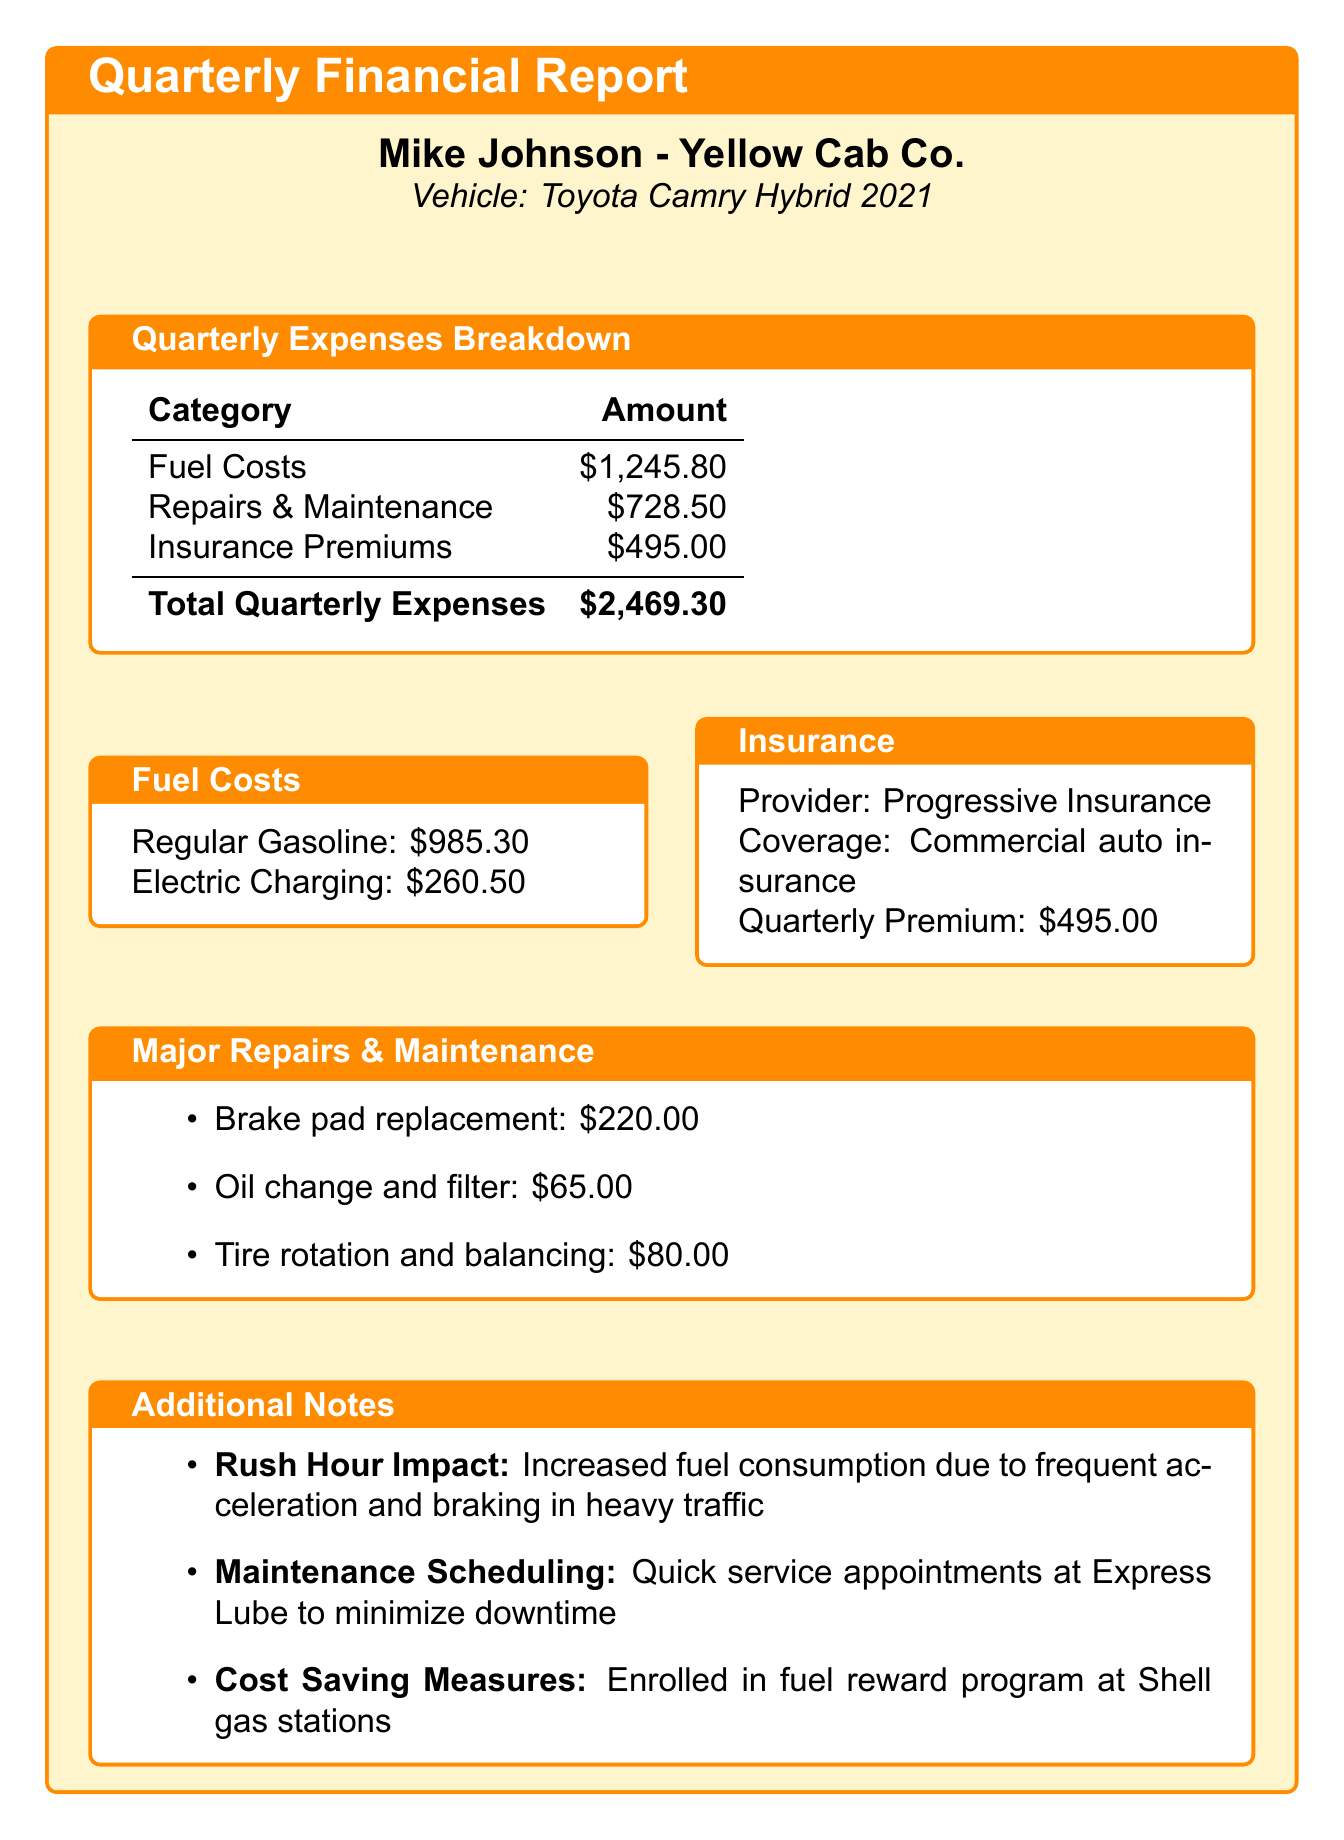What is the total quarterly expenses? The total quarterly expenses are summarized at the end of the document, which includes all costs.
Answer: $2,469.30 Who is the insurance provider? The document lists the insurance provider under the insurance section, identifying who covers the insurance.
Answer: Progressive Insurance What is the cost of the brake pad replacement? The cost for the brake pad replacement is detailed in the repairs and maintenance section, showing a specific repair expense.
Answer: $220.00 How much was spent on electric charging? The breakdown of fuel costs provides specific figures for electric charging, indicating the amount spent.
Answer: $260.50 What is the coverage type for the insurance? This detail is mentioned in the insurance section, clarifying the type of coverage provided by the insurer.
Answer: Commercial auto insurance How much was spent on regular gasoline? The fuel costs section breaks down the total amount spent on regular gasoline, providing a clear figure.
Answer: $985.30 What measures were taken to save costs? The additional notes section mentions cost-saving measures implemented, indicating proactive financial management.
Answer: Enrolled in fuel reward program at Shell gas stations What is the total amount spent on repairs and maintenance? The total expense for repairs and maintenance is provided in the quarterly expenses breakdown for clarity.
Answer: $728.50 What impact does rush hour have on fuel consumption? The additional notes section addresses how driving conditions during rush hour can affect costs, showing awareness of driving dynamics.
Answer: Increased fuel consumption due to frequent acceleration and braking in heavy traffic 